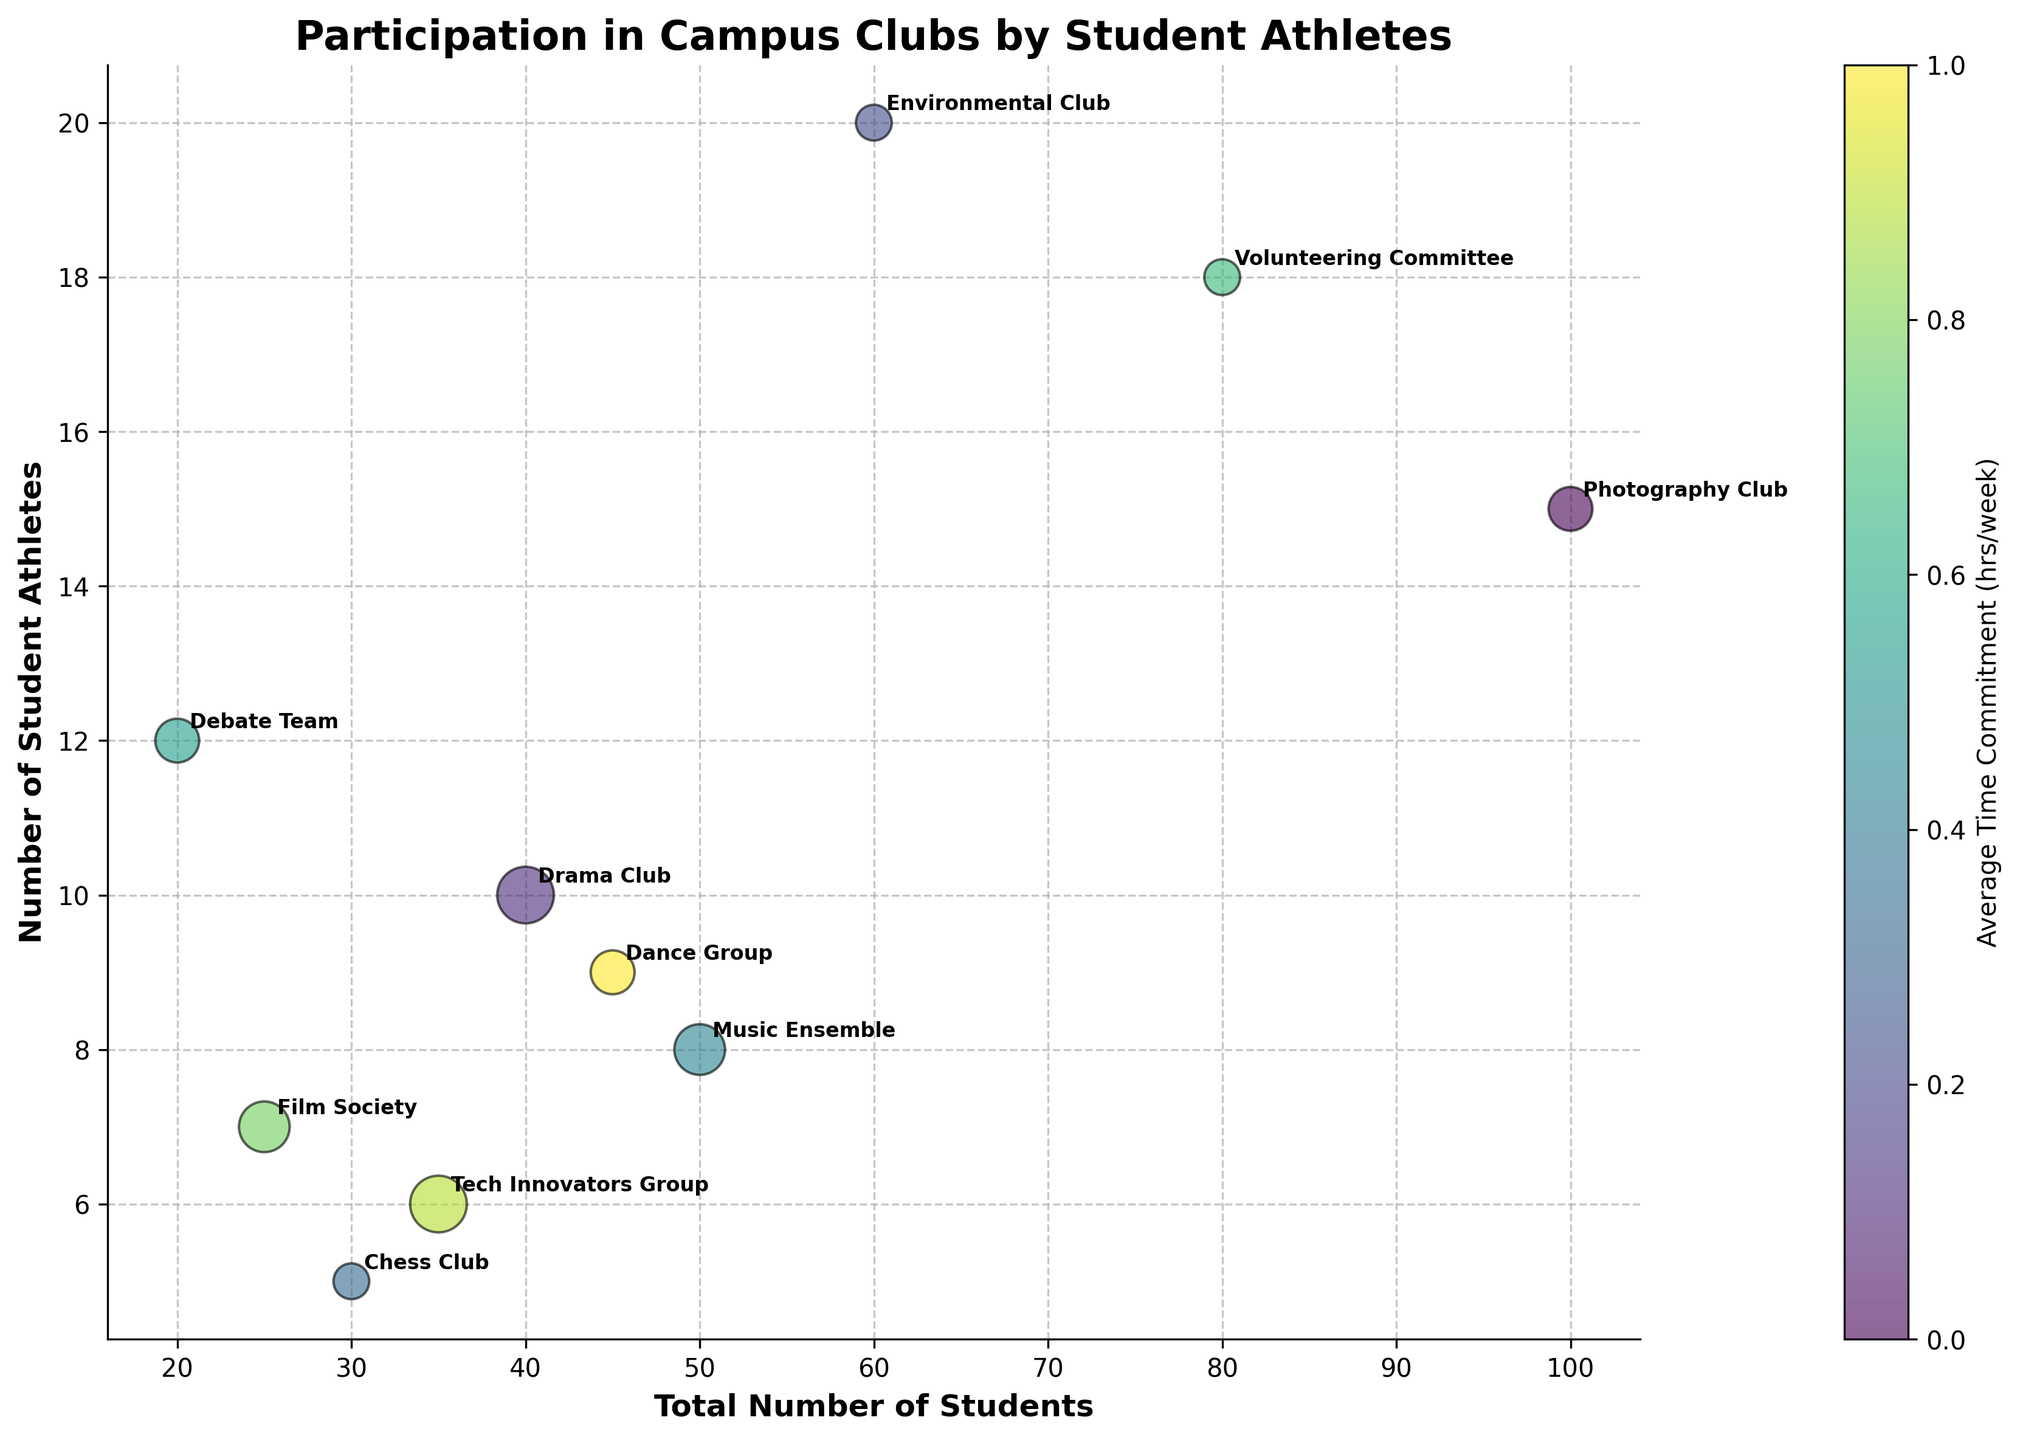Which club has the highest number of student athletes? The y-axis represents the number of student athletes. The Environmental Club is positioned the highest on the y-axis.
Answer: Environmental Club What is the total number of students in the Drama Club? The x-axis represents the total number of students. The Drama Club is positioned at 40 on the x-axis.
Answer: 40 Which club has the smallest number of bubbles? The Chess Club has the smallest bubbles, indicating the lowest average time commitment among displayed bubbles.
Answer: Chess Club How many hours per week do student athletes typically spend in the Tech Innovators Group? The bubble sizes represent the average time commitment. The bubble size for the Tech Innovators Group corresponds to 5 hours per week.
Answer: 5 hours In which club do student athletes spend the least time per week? The smallest bubbles indicate the lowest average time commitment. The Environmental Club, Chess Club, and Volunteering Committee are small and represent 2 hours per week each.
Answer: Environmental Club, Chess Club, Volunteering Committee What is the difference in the number of student athletes between the Drama Club and the Film Society? The Drama Club has 10 student athletes, and the Film Society has 7. The difference is 10 - 7 = 3.
Answer: 3 Which club has a higher number of student athletes, the Debate Team or the Dance Group? The y-axis represents the number of student athletes. The Debate Team is positioned higher on the y-axis than the Dance Group.
Answer: Debate Team Which club has the highest total number of students? The x-axis represents the total number of students. The Photography Club is positioned the farthest to the right on the x-axis.
Answer: Photography Club What is the average time commitment for the Music Ensemble? The bubble size represents the average time commitment. The Music Ensemble’s bubble size corresponds to 4 hours per week.
Answer: 4 hours If the average time commitment for the Film Society doubles, how does its bubble size compare to the Music Ensemble? The Film Society’s current bubble size represents 4 hours per week, doubling it would be 8 hours. Since 8 hours is bigger than the Music Ensemble's 4 hours, the bubble size would be larger.
Answer: Larger 